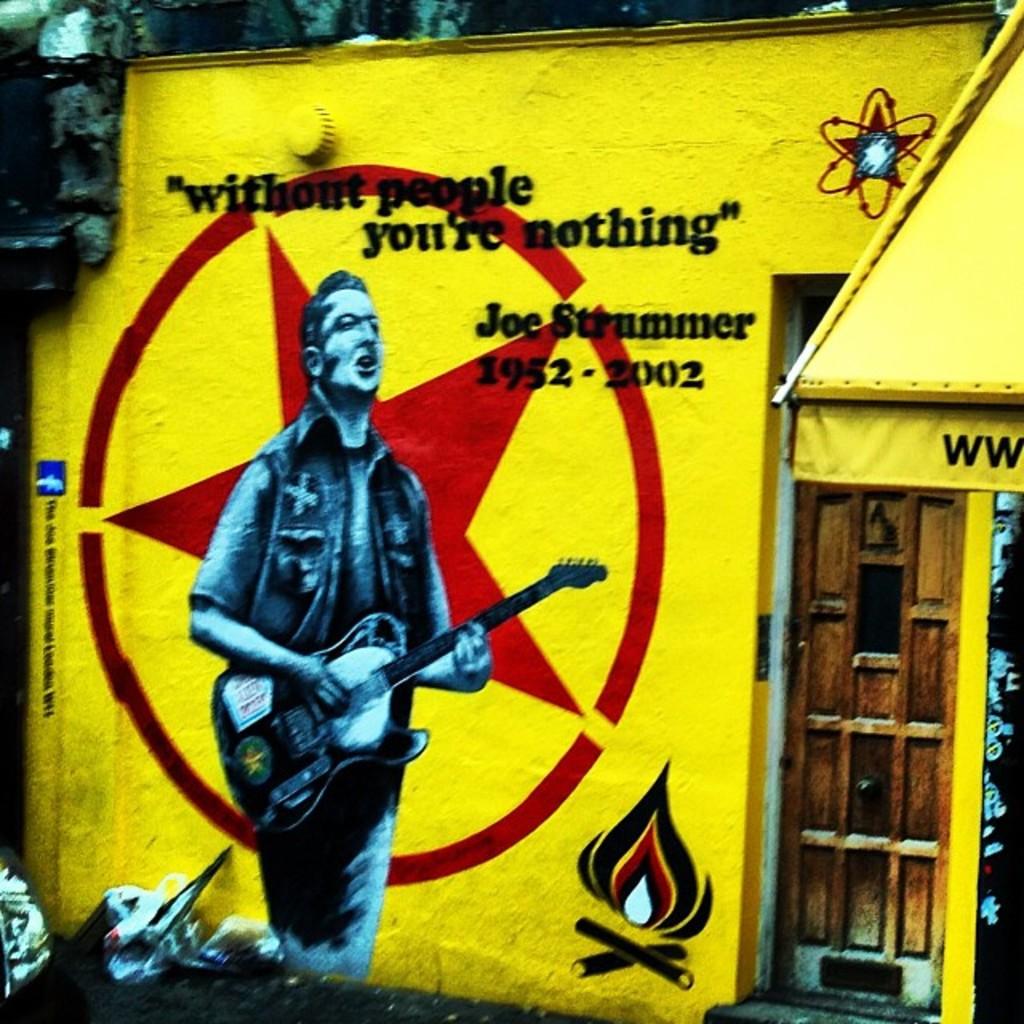Who is this singer?
Offer a terse response. Joe strummer. 